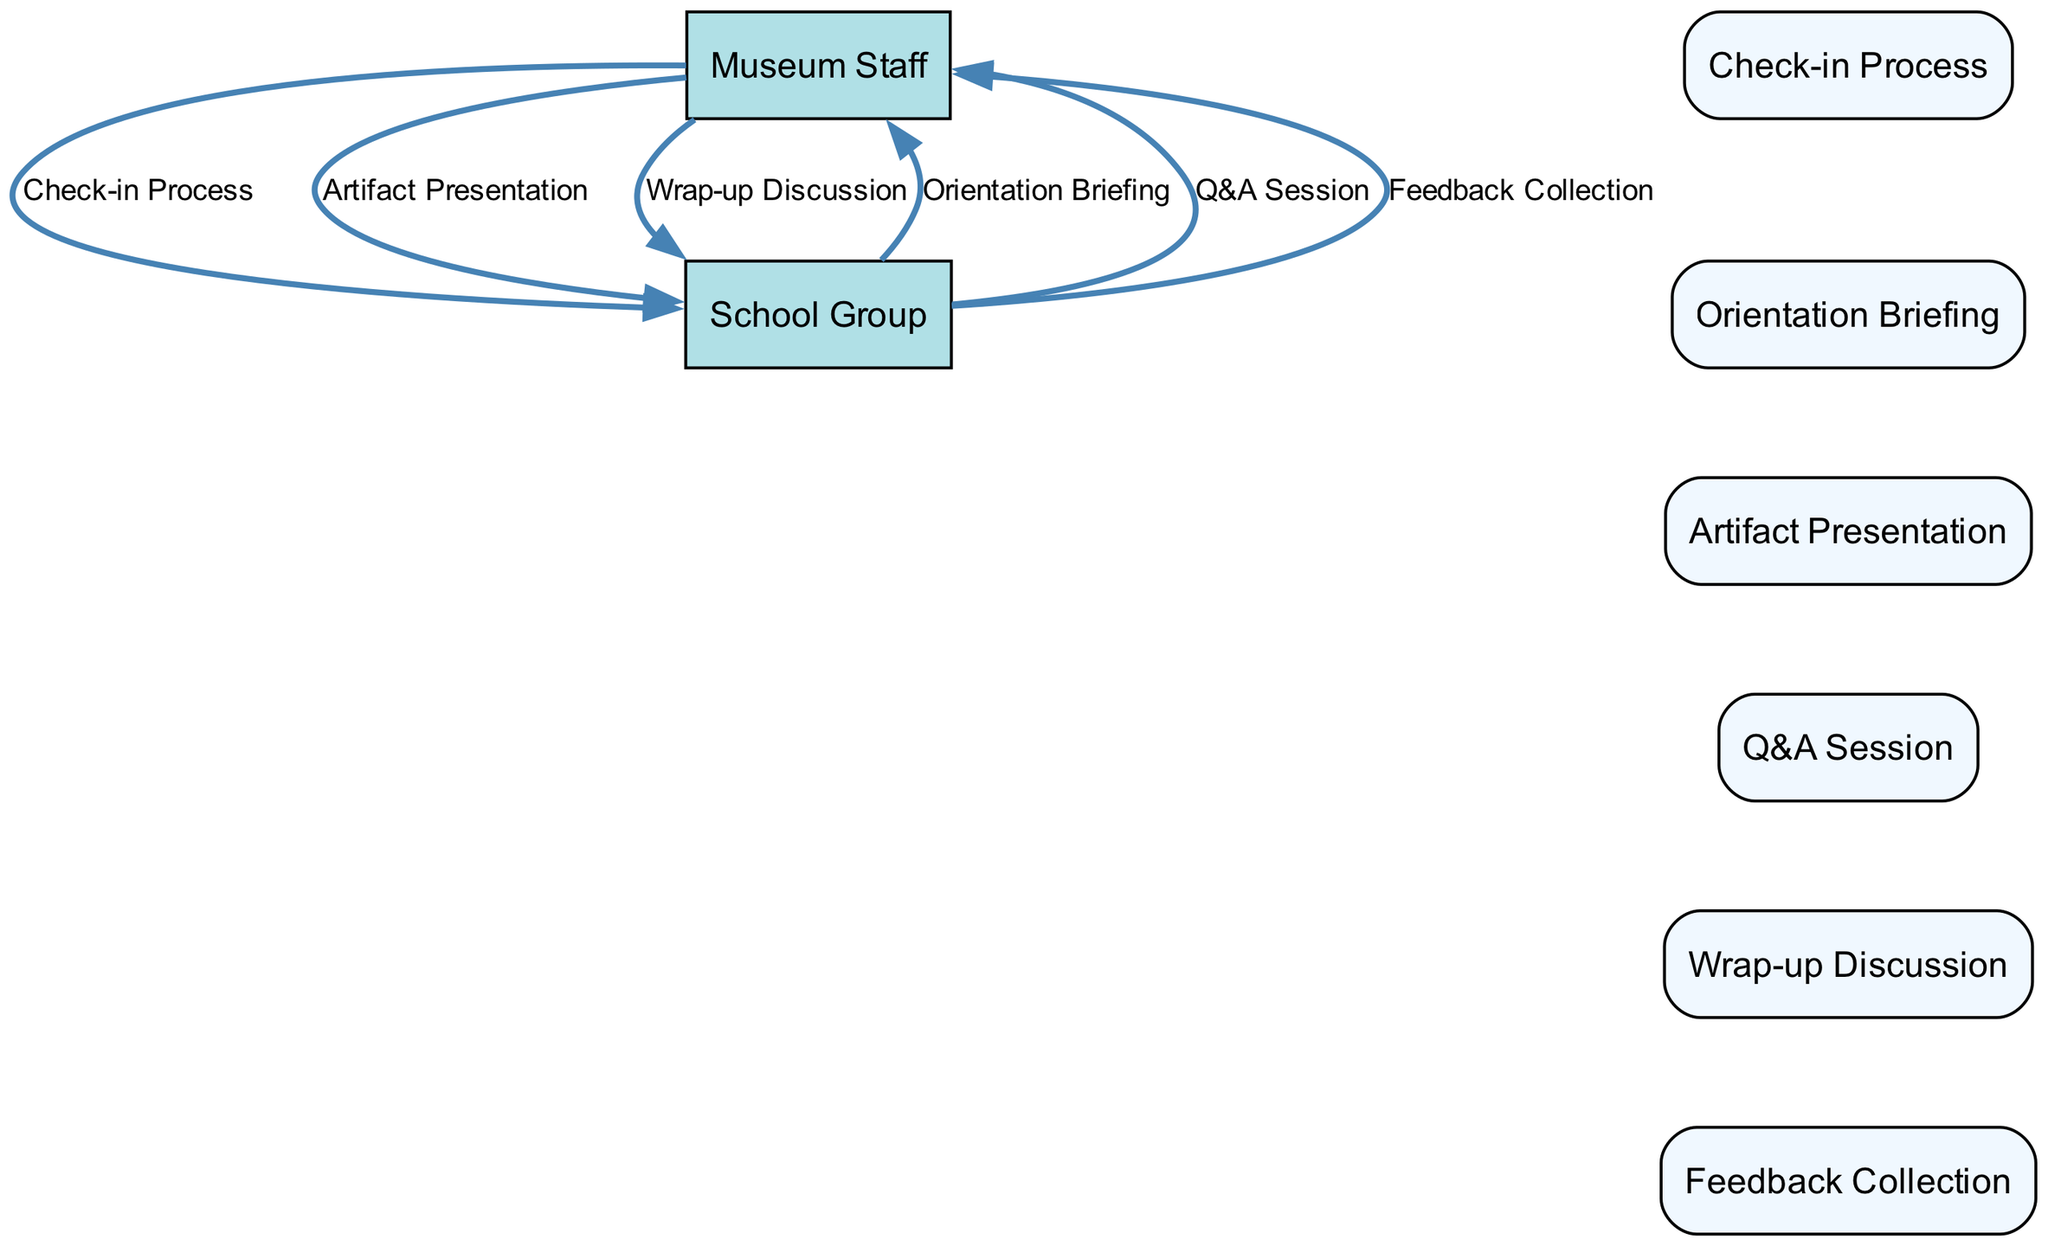What are the two main participants in the diagram? The diagram includes two main participants: the Museum Staff and the School Group, which are represented as nodes in the sequence diagram.
Answer: Museum Staff, School Group How many events are depicted in the sequence? The diagram outlines six events that take place during the guided tour, each represented by a separate node connected by edges.
Answer: Six What is the first event that occurs in the sequence? The first event in the diagram is the Check-in Process, which serves as the starting point for the interactions between the Museum Staff and the School Group.
Answer: Check-in Process Which event involves interaction between students and staff after the presentation? The Q&A Session follows the Artifact Presentation and involves direct interaction between the Museum Staff and the School Group, allowing students to ask questions.
Answer: Q&A Session What type of edge connects the Artifact Presentation to the Q&A Session? An edge labeled with the event Artifact Presentation connects to the Q&A Session, indicating the sequence of activities flowing from the presentation to the interactive questioning period.
Answer: Bold edge How does feedback collection relate to the previous events? Feedback Collection occurs after the Wrap-up Discussion, highlighting a final step of gathering students' impressions and insights about the tour experience, thus concluding the sequence.
Answer: Last event Which participant initiates the Orientation Briefing? The Museum Staff is the participant who initiates the Orientation Briefing, as all initial presentations and explanations are provided by them to lead the tour.
Answer: Museum Staff What activity follows the Wrap-up Discussion? Feedback Collection is the activity that directly follows the Wrap-up Discussion, as it aims to collect students' opinions on their tour experience right after the discussion concludes.
Answer: Feedback Collection 